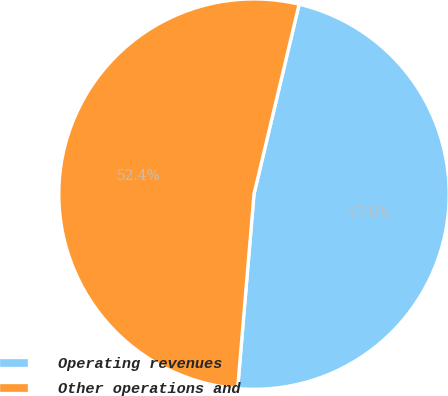<chart> <loc_0><loc_0><loc_500><loc_500><pie_chart><fcel>Operating revenues<fcel>Other operations and<nl><fcel>47.62%<fcel>52.38%<nl></chart> 